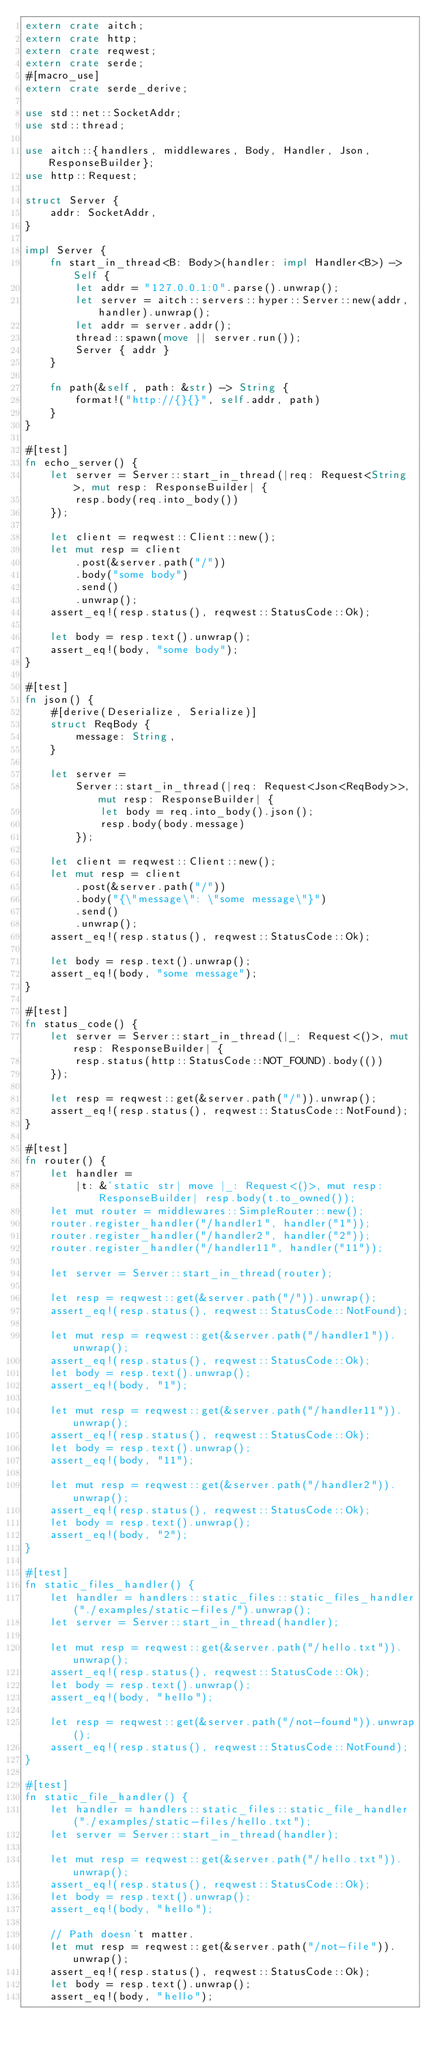<code> <loc_0><loc_0><loc_500><loc_500><_Rust_>extern crate aitch;
extern crate http;
extern crate reqwest;
extern crate serde;
#[macro_use]
extern crate serde_derive;

use std::net::SocketAddr;
use std::thread;

use aitch::{handlers, middlewares, Body, Handler, Json, ResponseBuilder};
use http::Request;

struct Server {
    addr: SocketAddr,
}

impl Server {
    fn start_in_thread<B: Body>(handler: impl Handler<B>) -> Self {
        let addr = "127.0.0.1:0".parse().unwrap();
        let server = aitch::servers::hyper::Server::new(addr, handler).unwrap();
        let addr = server.addr();
        thread::spawn(move || server.run());
        Server { addr }
    }

    fn path(&self, path: &str) -> String {
        format!("http://{}{}", self.addr, path)
    }
}

#[test]
fn echo_server() {
    let server = Server::start_in_thread(|req: Request<String>, mut resp: ResponseBuilder| {
        resp.body(req.into_body())
    });

    let client = reqwest::Client::new();
    let mut resp = client
        .post(&server.path("/"))
        .body("some body")
        .send()
        .unwrap();
    assert_eq!(resp.status(), reqwest::StatusCode::Ok);

    let body = resp.text().unwrap();
    assert_eq!(body, "some body");
}

#[test]
fn json() {
    #[derive(Deserialize, Serialize)]
    struct ReqBody {
        message: String,
    }

    let server =
        Server::start_in_thread(|req: Request<Json<ReqBody>>, mut resp: ResponseBuilder| {
            let body = req.into_body().json();
            resp.body(body.message)
        });

    let client = reqwest::Client::new();
    let mut resp = client
        .post(&server.path("/"))
        .body("{\"message\": \"some message\"}")
        .send()
        .unwrap();
    assert_eq!(resp.status(), reqwest::StatusCode::Ok);

    let body = resp.text().unwrap();
    assert_eq!(body, "some message");
}

#[test]
fn status_code() {
    let server = Server::start_in_thread(|_: Request<()>, mut resp: ResponseBuilder| {
        resp.status(http::StatusCode::NOT_FOUND).body(())
    });

    let resp = reqwest::get(&server.path("/")).unwrap();
    assert_eq!(resp.status(), reqwest::StatusCode::NotFound);
}

#[test]
fn router() {
    let handler =
        |t: &'static str| move |_: Request<()>, mut resp: ResponseBuilder| resp.body(t.to_owned());
    let mut router = middlewares::SimpleRouter::new();
    router.register_handler("/handler1", handler("1"));
    router.register_handler("/handler2", handler("2"));
    router.register_handler("/handler11", handler("11"));

    let server = Server::start_in_thread(router);

    let resp = reqwest::get(&server.path("/")).unwrap();
    assert_eq!(resp.status(), reqwest::StatusCode::NotFound);

    let mut resp = reqwest::get(&server.path("/handler1")).unwrap();
    assert_eq!(resp.status(), reqwest::StatusCode::Ok);
    let body = resp.text().unwrap();
    assert_eq!(body, "1");

    let mut resp = reqwest::get(&server.path("/handler11")).unwrap();
    assert_eq!(resp.status(), reqwest::StatusCode::Ok);
    let body = resp.text().unwrap();
    assert_eq!(body, "11");

    let mut resp = reqwest::get(&server.path("/handler2")).unwrap();
    assert_eq!(resp.status(), reqwest::StatusCode::Ok);
    let body = resp.text().unwrap();
    assert_eq!(body, "2");
}

#[test]
fn static_files_handler() {
    let handler = handlers::static_files::static_files_handler("./examples/static-files/").unwrap();
    let server = Server::start_in_thread(handler);

    let mut resp = reqwest::get(&server.path("/hello.txt")).unwrap();
    assert_eq!(resp.status(), reqwest::StatusCode::Ok);
    let body = resp.text().unwrap();
    assert_eq!(body, "hello");

    let resp = reqwest::get(&server.path("/not-found")).unwrap();
    assert_eq!(resp.status(), reqwest::StatusCode::NotFound);
}

#[test]
fn static_file_handler() {
    let handler = handlers::static_files::static_file_handler("./examples/static-files/hello.txt");
    let server = Server::start_in_thread(handler);

    let mut resp = reqwest::get(&server.path("/hello.txt")).unwrap();
    assert_eq!(resp.status(), reqwest::StatusCode::Ok);
    let body = resp.text().unwrap();
    assert_eq!(body, "hello");

    // Path doesn't matter.
    let mut resp = reqwest::get(&server.path("/not-file")).unwrap();
    assert_eq!(resp.status(), reqwest::StatusCode::Ok);
    let body = resp.text().unwrap();
    assert_eq!(body, "hello");</code> 